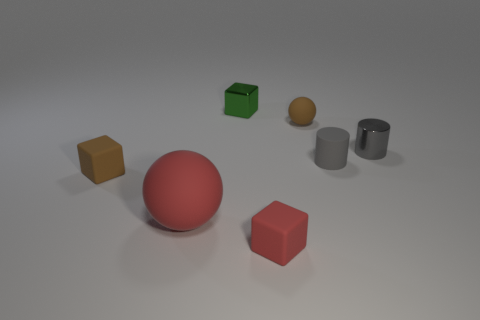What number of objects are tiny rubber cubes that are left of the metallic cube or large red spheres?
Your response must be concise. 2. There is a big rubber thing; does it have the same color as the matte cube that is in front of the red matte sphere?
Your answer should be very brief. Yes. Is there any other thing that has the same size as the red ball?
Keep it short and to the point. No. There is a green metallic block left of the matte ball to the right of the green block; how big is it?
Provide a short and direct response. Small. What number of things are small brown shiny cubes or small rubber objects that are on the left side of the small green metallic thing?
Your response must be concise. 1. There is a metal object that is to the left of the small red matte block; is it the same shape as the small red thing?
Provide a succinct answer. Yes. What number of small cylinders are behind the brown thing in front of the cylinder that is behind the gray matte cylinder?
Provide a short and direct response. 2. How many things are either red spheres or rubber cubes?
Offer a very short reply. 3. There is a big red matte thing; is it the same shape as the small brown matte thing that is right of the tiny red rubber object?
Provide a short and direct response. Yes. What is the shape of the shiny thing in front of the small green cube?
Offer a very short reply. Cylinder. 